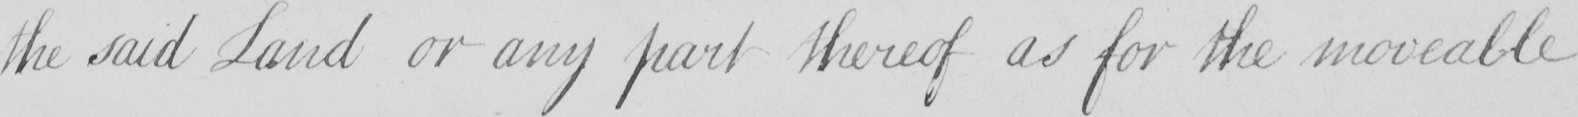Please provide the text content of this handwritten line. the said Land or any part thereof as for the moveable 